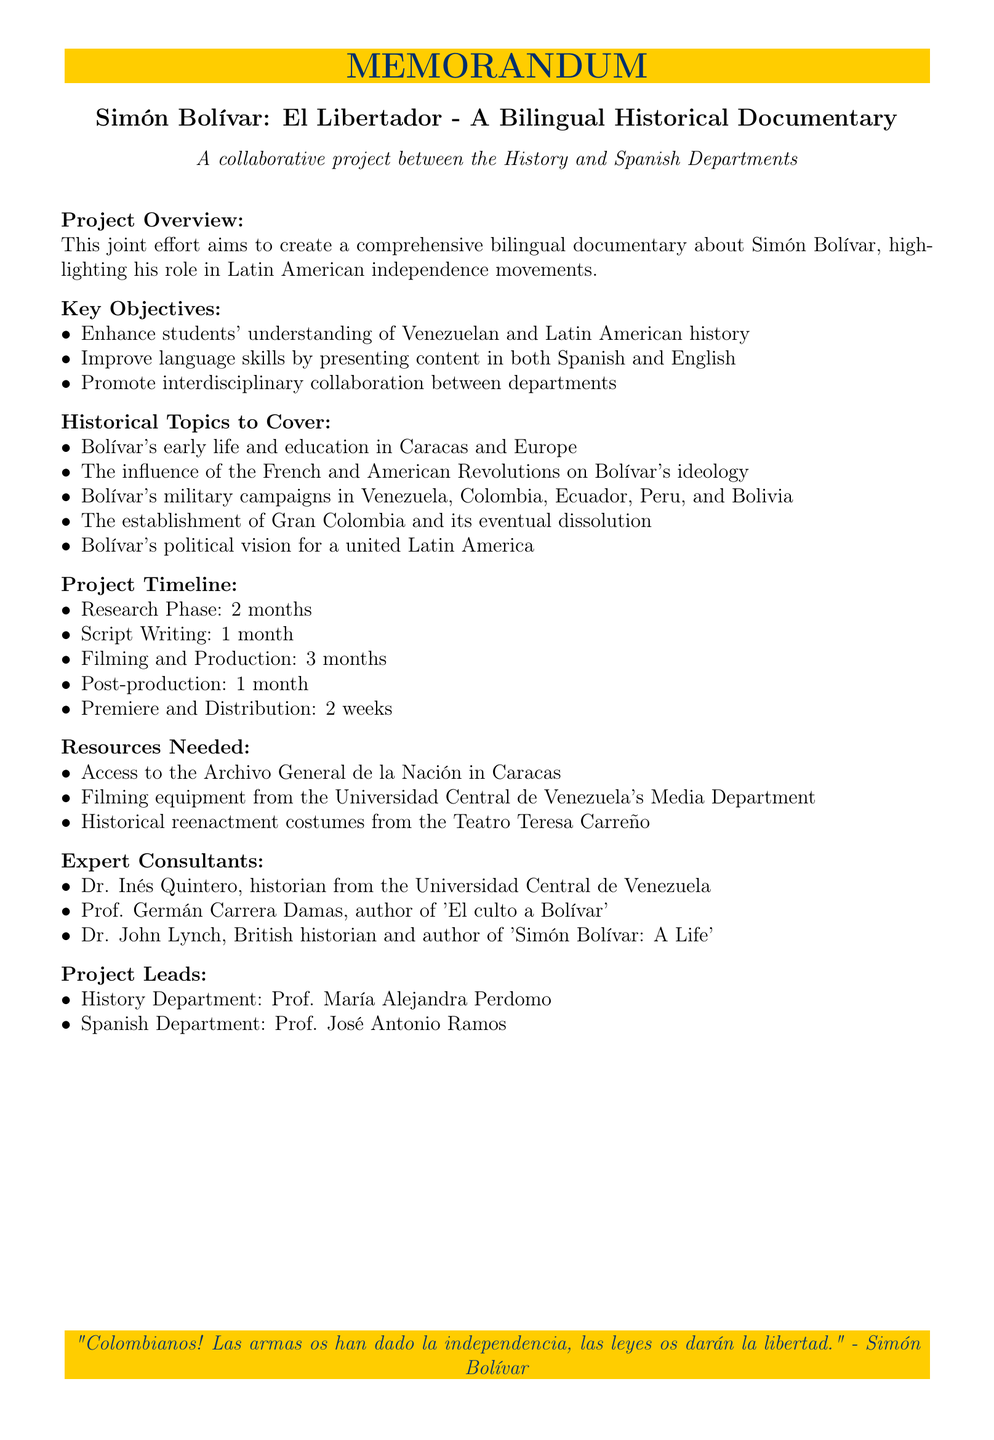What is the project title? The project title is the first line of the document that outlines the purpose of the memo.
Answer: Simón Bolívar: El Libertador - A Bilingual Historical Documentary What are the collaborating departments? The collaborating departments are specified in the list under "collaborating_departments".
Answer: History Department, Spanish Department How long is the research phase? The duration of the research phase is listed under "project timeline".
Answer: 2 months Who are the expert consultants? The expert consultants are named in the section dedicated to consulting resources.
Answer: Dr. Inés Quintero, Prof. Germán Carrera Damas, Dr. John Lynch What is one of the key objectives of the project? The key objectives are listed under "Key Objectives" and require identifying one of the main goals of the project.
Answer: Improve language skills by presenting content in both Spanish and English How many potential filming locations are mentioned? The document specifies the number of potential filming locations in the related section.
Answer: 4 What is the expected outcome of the project? The expected outcome is detailed in the list under "Expected Outcomes", indicating what the project aims to achieve.
Answer: A 90-minute bilingual documentary suitable for classroom use Who is the project lead from the Spanish Department? The project leads are explicitly mentioned for both departments in the document.
Answer: Prof. José Antonio Ramos 